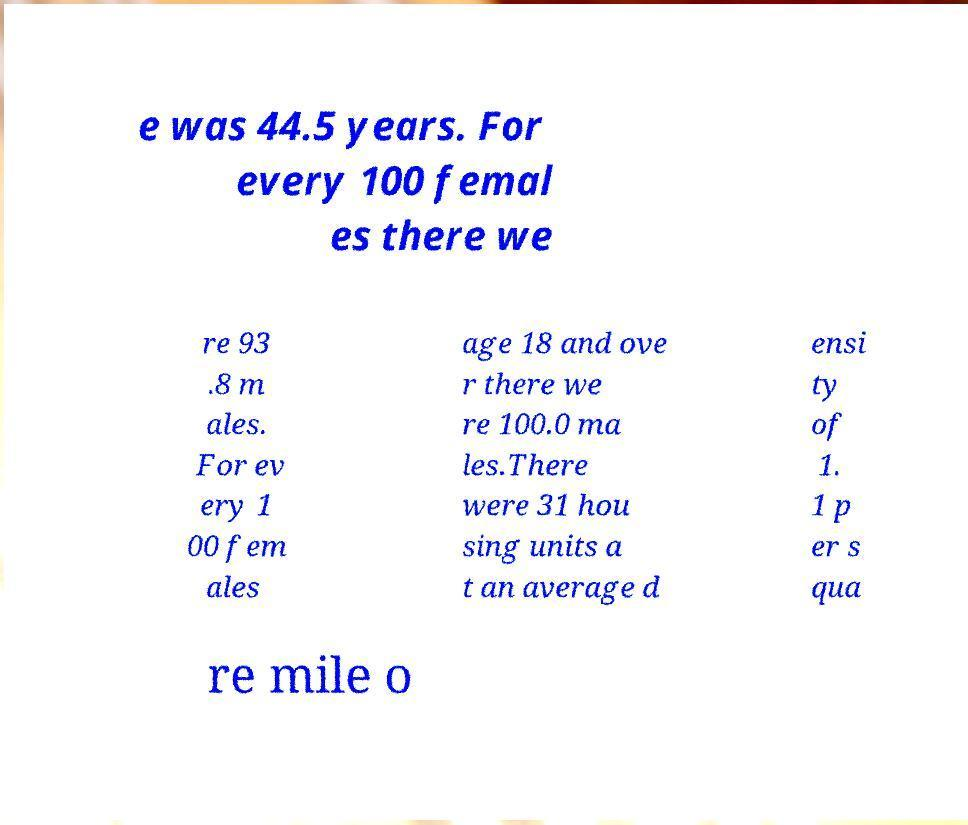There's text embedded in this image that I need extracted. Can you transcribe it verbatim? e was 44.5 years. For every 100 femal es there we re 93 .8 m ales. For ev ery 1 00 fem ales age 18 and ove r there we re 100.0 ma les.There were 31 hou sing units a t an average d ensi ty of 1. 1 p er s qua re mile o 